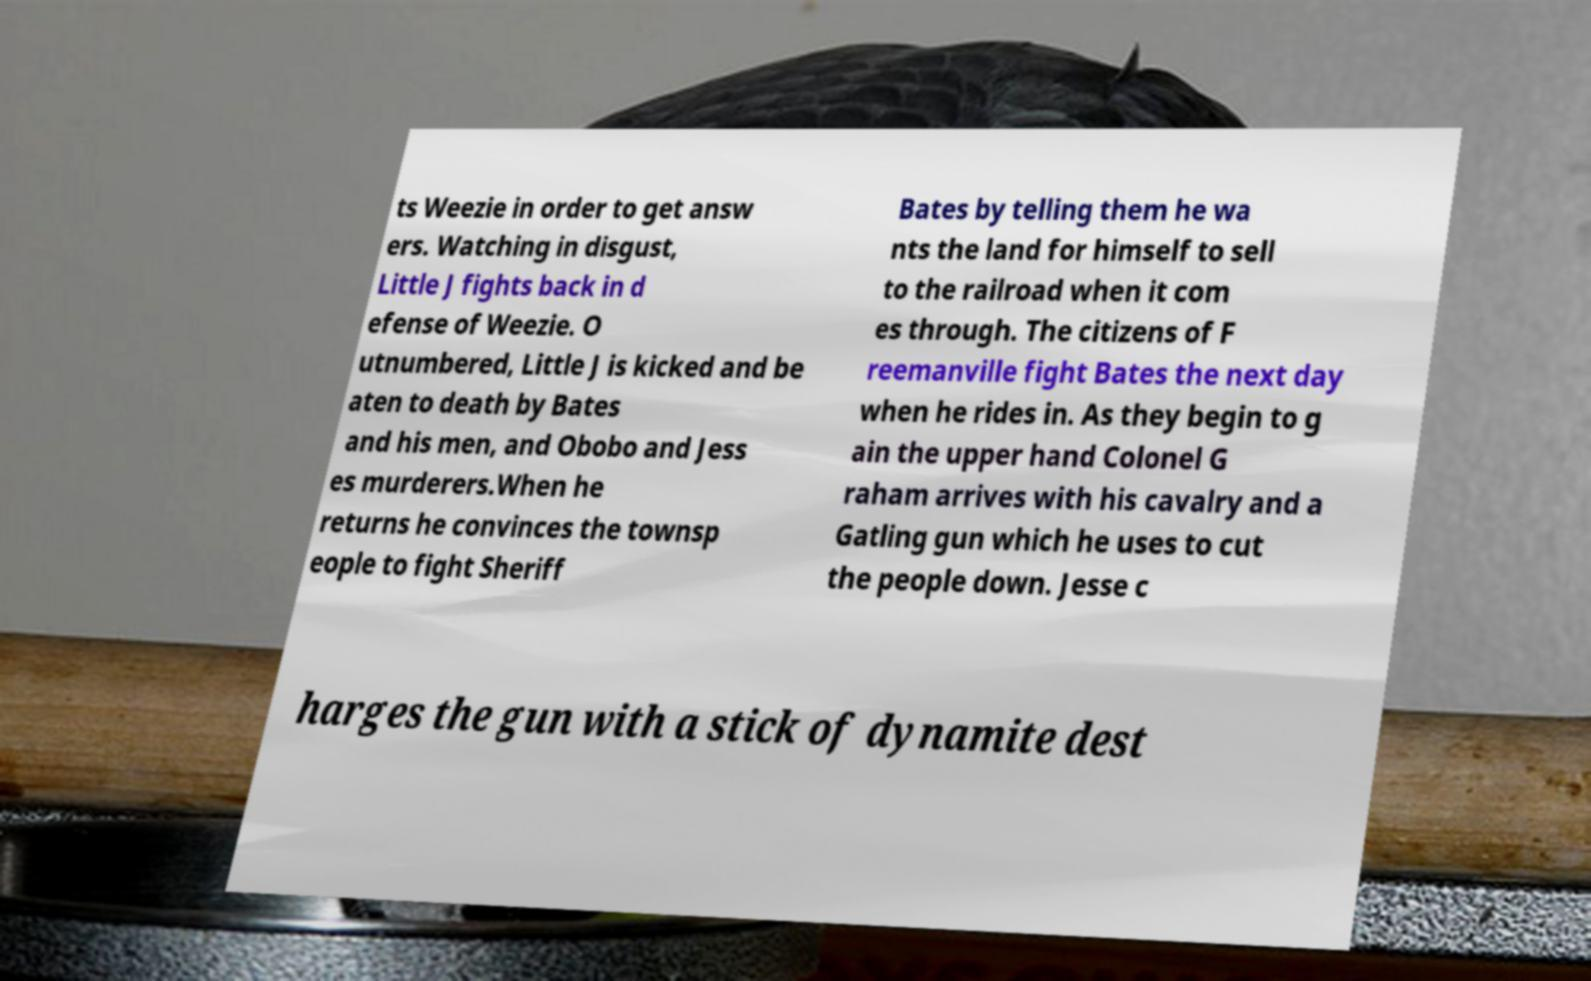What messages or text are displayed in this image? I need them in a readable, typed format. ts Weezie in order to get answ ers. Watching in disgust, Little J fights back in d efense of Weezie. O utnumbered, Little J is kicked and be aten to death by Bates and his men, and Obobo and Jess es murderers.When he returns he convinces the townsp eople to fight Sheriff Bates by telling them he wa nts the land for himself to sell to the railroad when it com es through. The citizens of F reemanville fight Bates the next day when he rides in. As they begin to g ain the upper hand Colonel G raham arrives with his cavalry and a Gatling gun which he uses to cut the people down. Jesse c harges the gun with a stick of dynamite dest 